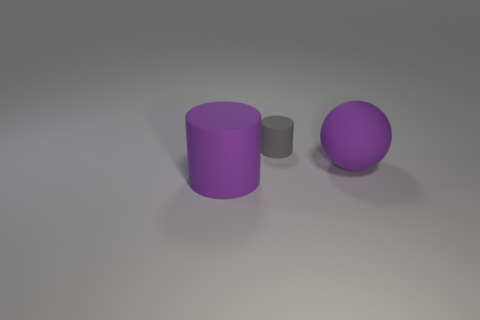How many gray matte cylinders are behind the gray thing?
Your answer should be very brief. 0. Is the color of the small matte cylinder the same as the ball?
Give a very brief answer. No. What number of rubber cylinders are the same color as the small rubber object?
Offer a terse response. 0. Is the number of large metal spheres greater than the number of matte balls?
Give a very brief answer. No. How big is the matte thing that is both in front of the small rubber object and behind the big matte cylinder?
Offer a terse response. Large. Does the thing right of the gray thing have the same material as the big cylinder in front of the purple sphere?
Make the answer very short. Yes. The purple matte object that is the same size as the sphere is what shape?
Keep it short and to the point. Cylinder. Are there fewer purple objects than small purple spheres?
Make the answer very short. No. There is a big purple matte object that is behind the large purple cylinder; is there a big purple cylinder that is behind it?
Your response must be concise. No. There is a object in front of the large purple object to the right of the gray matte cylinder; are there any purple matte things behind it?
Offer a very short reply. Yes. 